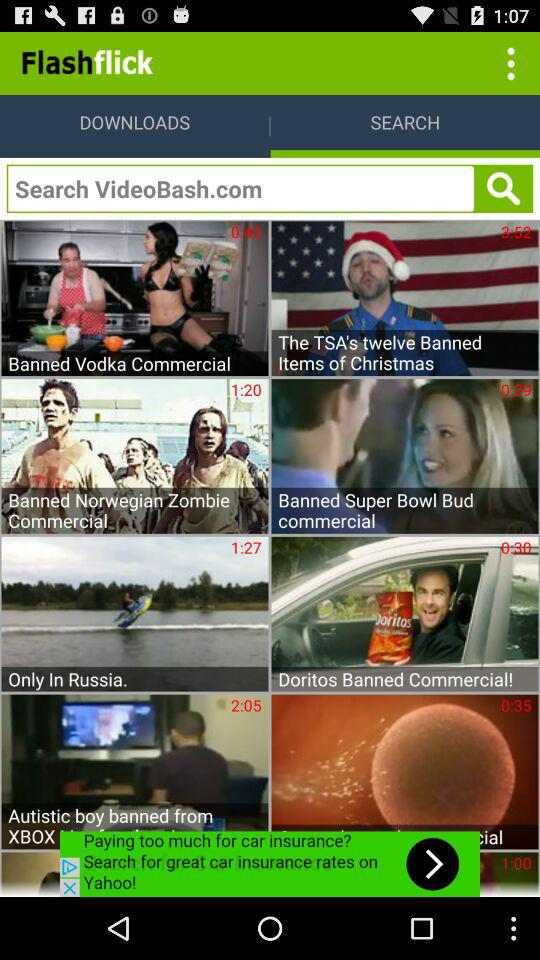Which tab is selected? The selected tab is "SEARCH". 